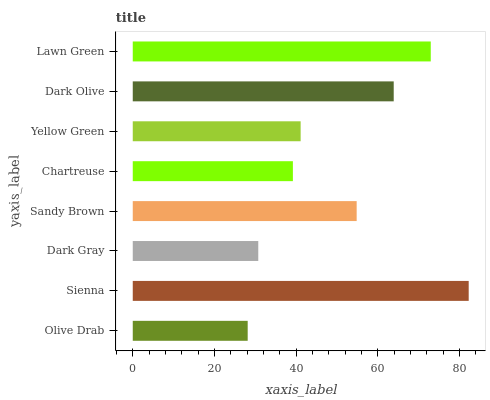Is Olive Drab the minimum?
Answer yes or no. Yes. Is Sienna the maximum?
Answer yes or no. Yes. Is Dark Gray the minimum?
Answer yes or no. No. Is Dark Gray the maximum?
Answer yes or no. No. Is Sienna greater than Dark Gray?
Answer yes or no. Yes. Is Dark Gray less than Sienna?
Answer yes or no. Yes. Is Dark Gray greater than Sienna?
Answer yes or no. No. Is Sienna less than Dark Gray?
Answer yes or no. No. Is Sandy Brown the high median?
Answer yes or no. Yes. Is Yellow Green the low median?
Answer yes or no. Yes. Is Lawn Green the high median?
Answer yes or no. No. Is Chartreuse the low median?
Answer yes or no. No. 